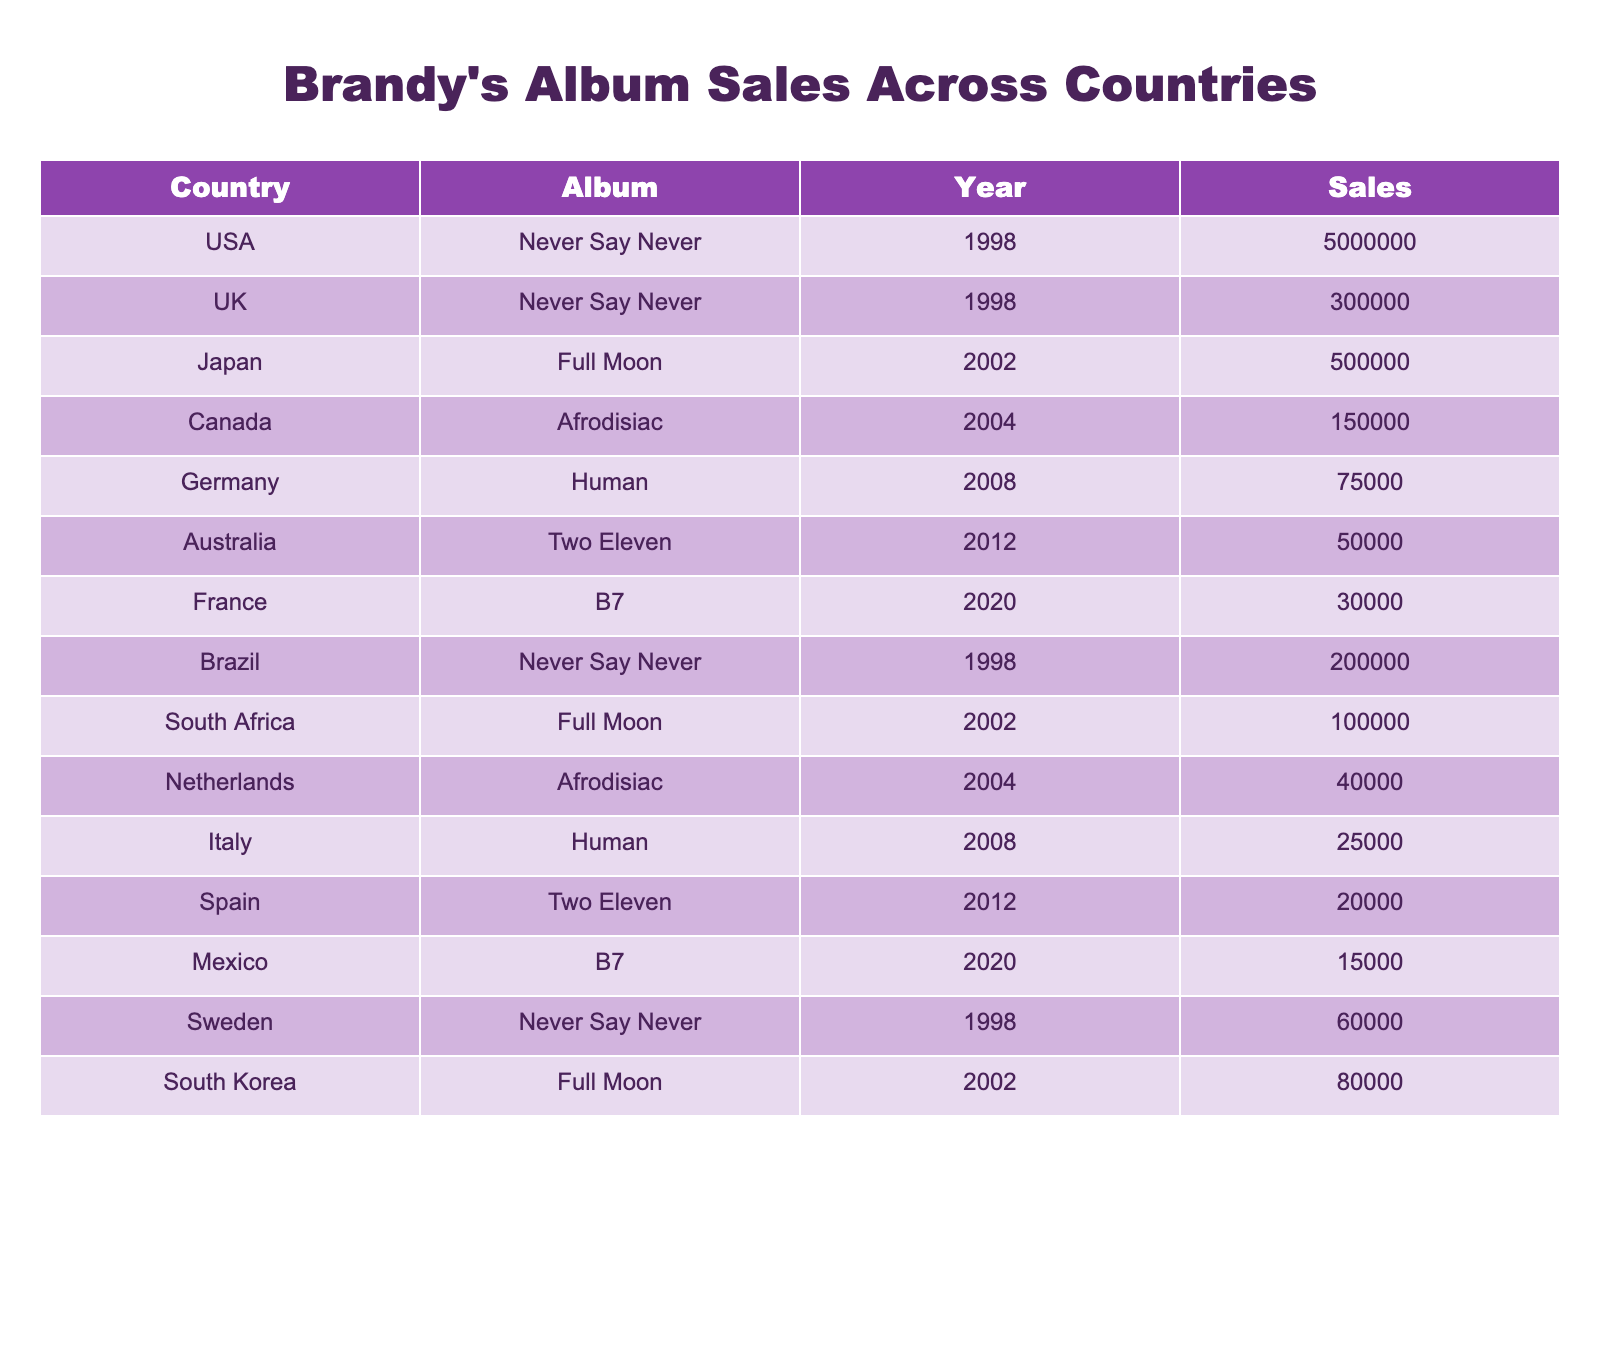What is the total sales of "Never Say Never" in the USA? The table shows that the sales of "Never Say Never" in the USA is listed as 5,000,000.
Answer: 5,000,000 Which country had the lowest album sales listed in the table? The table indicates that Mexico had the lowest album sales with 15,000 for the album "B7".
Answer: Mexico What is the total sales of Brandy's albums in Canada? The table lists the album sales in Canada as 150,000 for "Afrodisiac". There are no other entries for Canada, so this is the total.
Answer: 150,000 Did "Full Moon" have more sales in South Korea than in Japan? The table shows "Full Moon" sales as 500,000 in Japan and 80,000 in South Korea, indicating Japan had higher sales.
Answer: No Which album sold the most overall across all countries mentioned? The highest sales figure in the table is 5,000,000 for "Never Say Never" in the USA, surpassing all other albums.
Answer: Never Say Never What is the average sales of all albums in the UK? The table shows only one entry for the UK with "Never Say Never" selling 300,000. Hence, the average is simply 300,000 since there’s only one data point.
Answer: 300,000 How many albums had sales exceeding 200,000? Analyzing the table, "Never Say Never" in the USA has 5,000,000, "Never Say Never" in Brazil has 200,000, and "Full Moon" in Japan has 500,000. This results in three albums exceeding 200,000 in sales.
Answer: 3 Is there any album that sold less than 50,000 in Australia, South Africa, and Spain? The table shows "Two Eleven" with 50,000 in Australia, "Full Moon" with 100,000 in South Africa, and "Two Eleven" with 20,000 in Spain. Therefore, "Two Eleven" in Spain sold less than 50,000.
Answer: Yes What is the total sales of Brandy’s albums in Europe? Summing up the sales from the UK (300,000), Germany (75,000), France (30,000), the Netherlands (40,000), Italy (25,000), Sweden (60,000), and Spain (20,000), the total comes to 550,000.
Answer: 550,000 How many albums were released after 2000? The table lists "Full Moon" (2002), "Afrodisiac" (2004), "Human" (2008), "Two Eleven" (2012), and "B7" (2020) for a total of 5 albums released after 2000.
Answer: 5 